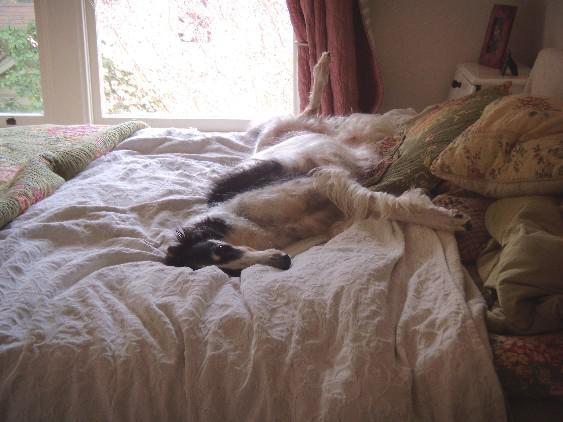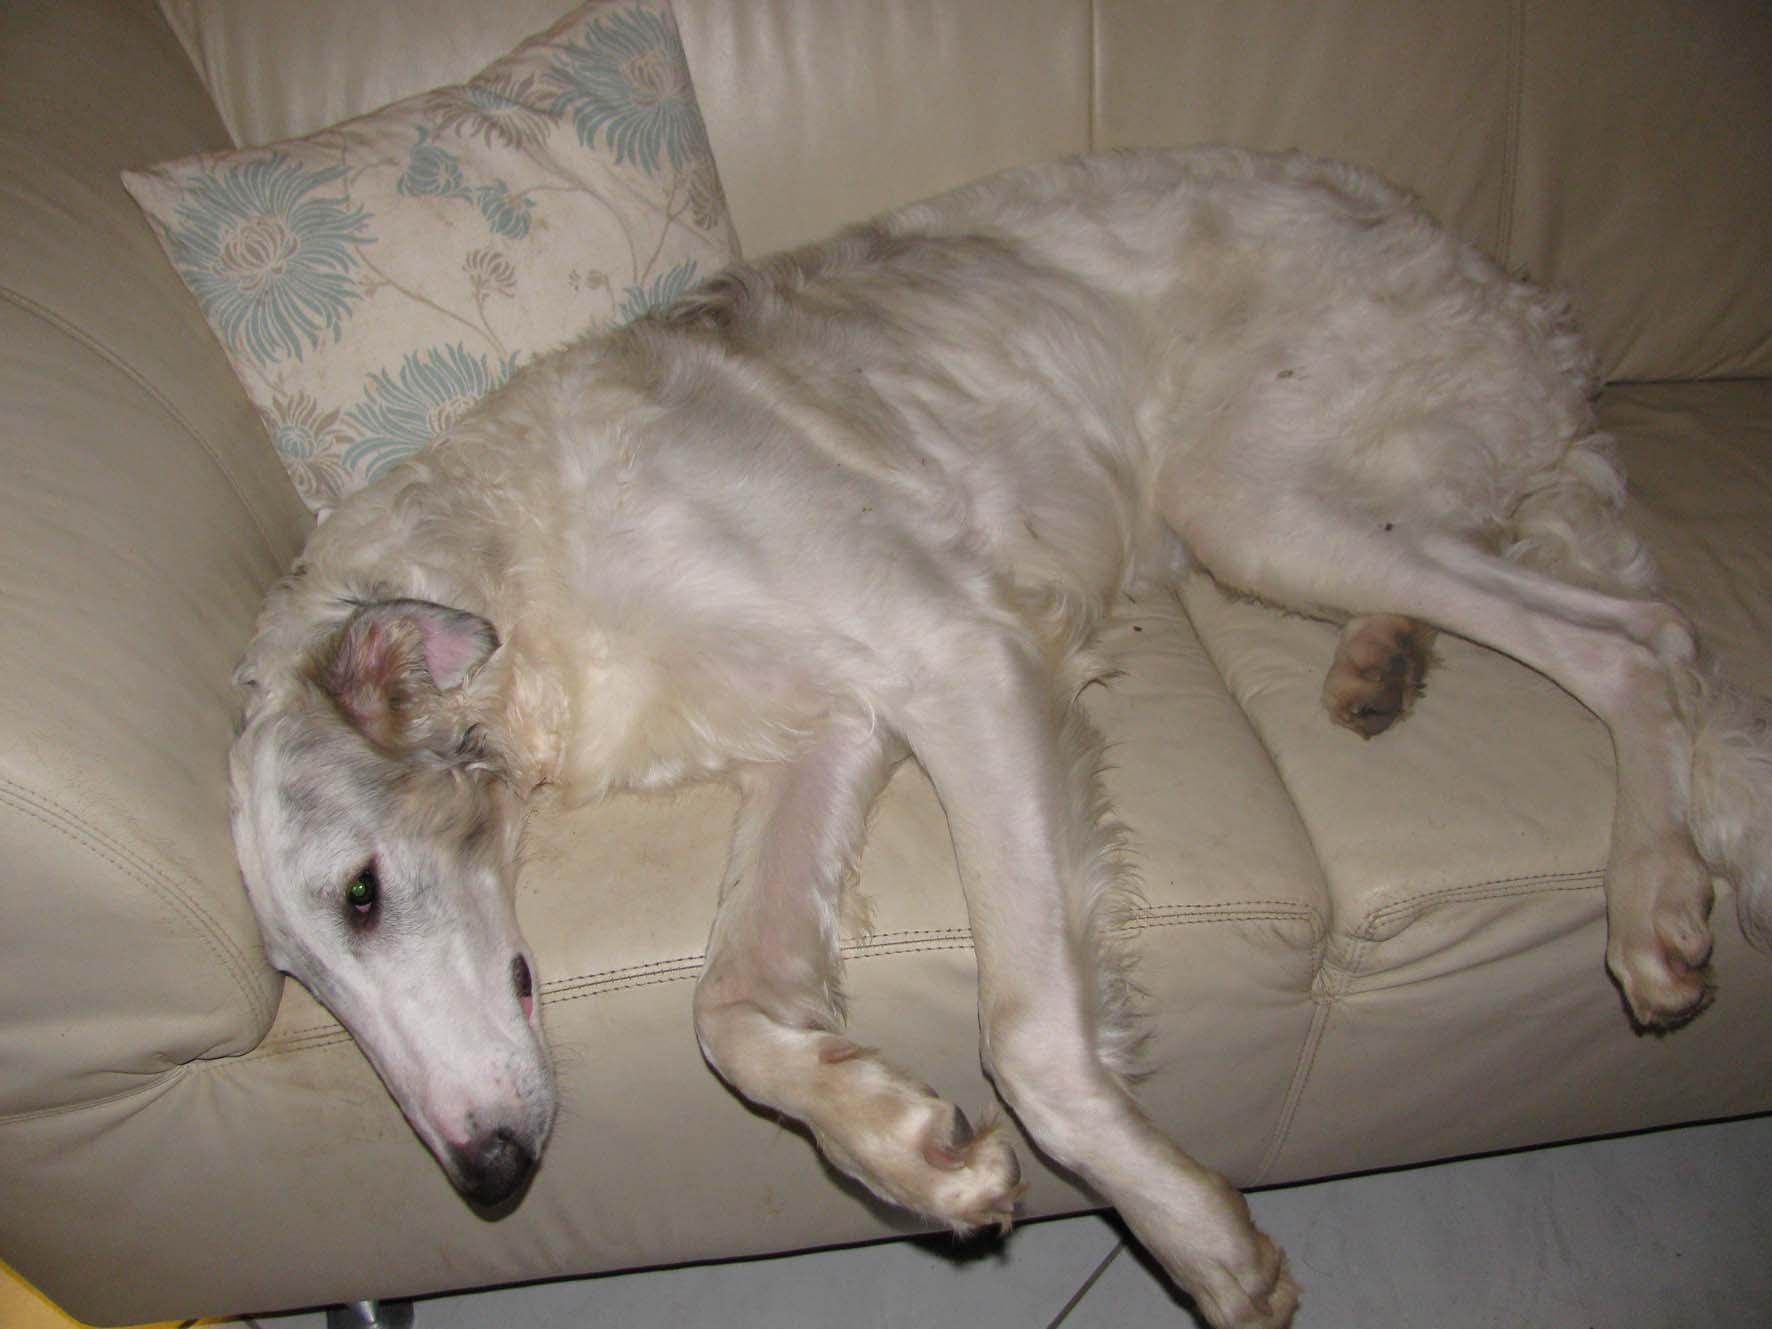The first image is the image on the left, the second image is the image on the right. For the images shown, is this caption "The dog in the image on the right is lying on a couch." true? Answer yes or no. Yes. The first image is the image on the left, the second image is the image on the right. Analyze the images presented: Is the assertion "A dog is lying on the floor on a rug." valid? Answer yes or no. No. 